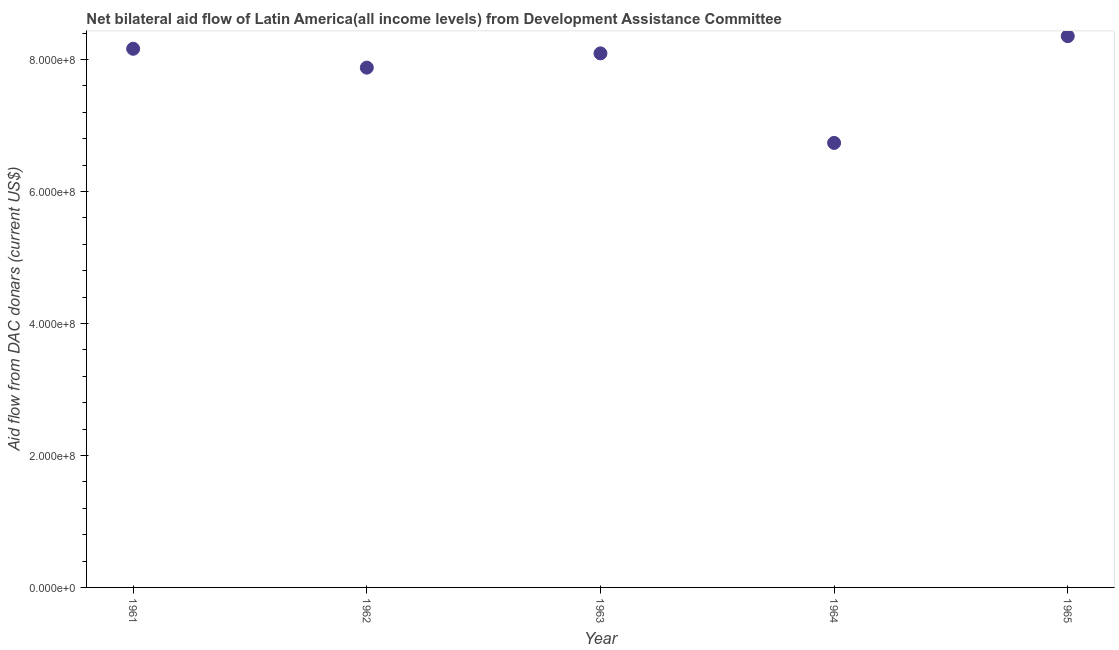What is the net bilateral aid flows from dac donors in 1964?
Provide a succinct answer. 6.74e+08. Across all years, what is the maximum net bilateral aid flows from dac donors?
Offer a terse response. 8.35e+08. Across all years, what is the minimum net bilateral aid flows from dac donors?
Give a very brief answer. 6.74e+08. In which year was the net bilateral aid flows from dac donors maximum?
Provide a short and direct response. 1965. In which year was the net bilateral aid flows from dac donors minimum?
Your response must be concise. 1964. What is the sum of the net bilateral aid flows from dac donors?
Keep it short and to the point. 3.92e+09. What is the difference between the net bilateral aid flows from dac donors in 1962 and 1963?
Your answer should be very brief. -2.16e+07. What is the average net bilateral aid flows from dac donors per year?
Make the answer very short. 7.84e+08. What is the median net bilateral aid flows from dac donors?
Offer a terse response. 8.09e+08. In how many years, is the net bilateral aid flows from dac donors greater than 680000000 US$?
Make the answer very short. 4. Do a majority of the years between 1961 and 1964 (inclusive) have net bilateral aid flows from dac donors greater than 760000000 US$?
Provide a short and direct response. Yes. What is the ratio of the net bilateral aid flows from dac donors in 1961 to that in 1964?
Give a very brief answer. 1.21. Is the difference between the net bilateral aid flows from dac donors in 1962 and 1965 greater than the difference between any two years?
Offer a very short reply. No. What is the difference between the highest and the second highest net bilateral aid flows from dac donors?
Provide a short and direct response. 1.91e+07. Is the sum of the net bilateral aid flows from dac donors in 1961 and 1963 greater than the maximum net bilateral aid flows from dac donors across all years?
Offer a terse response. Yes. What is the difference between the highest and the lowest net bilateral aid flows from dac donors?
Make the answer very short. 1.62e+08. What is the title of the graph?
Ensure brevity in your answer.  Net bilateral aid flow of Latin America(all income levels) from Development Assistance Committee. What is the label or title of the X-axis?
Provide a short and direct response. Year. What is the label or title of the Y-axis?
Your answer should be compact. Aid flow from DAC donars (current US$). What is the Aid flow from DAC donars (current US$) in 1961?
Offer a terse response. 8.16e+08. What is the Aid flow from DAC donars (current US$) in 1962?
Ensure brevity in your answer.  7.88e+08. What is the Aid flow from DAC donars (current US$) in 1963?
Offer a very short reply. 8.09e+08. What is the Aid flow from DAC donars (current US$) in 1964?
Ensure brevity in your answer.  6.74e+08. What is the Aid flow from DAC donars (current US$) in 1965?
Your answer should be compact. 8.35e+08. What is the difference between the Aid flow from DAC donars (current US$) in 1961 and 1962?
Offer a terse response. 2.86e+07. What is the difference between the Aid flow from DAC donars (current US$) in 1961 and 1963?
Make the answer very short. 6.97e+06. What is the difference between the Aid flow from DAC donars (current US$) in 1961 and 1964?
Ensure brevity in your answer.  1.43e+08. What is the difference between the Aid flow from DAC donars (current US$) in 1961 and 1965?
Give a very brief answer. -1.91e+07. What is the difference between the Aid flow from DAC donars (current US$) in 1962 and 1963?
Offer a very short reply. -2.16e+07. What is the difference between the Aid flow from DAC donars (current US$) in 1962 and 1964?
Make the answer very short. 1.14e+08. What is the difference between the Aid flow from DAC donars (current US$) in 1962 and 1965?
Your answer should be very brief. -4.77e+07. What is the difference between the Aid flow from DAC donars (current US$) in 1963 and 1964?
Provide a succinct answer. 1.36e+08. What is the difference between the Aid flow from DAC donars (current US$) in 1963 and 1965?
Make the answer very short. -2.61e+07. What is the difference between the Aid flow from DAC donars (current US$) in 1964 and 1965?
Give a very brief answer. -1.62e+08. What is the ratio of the Aid flow from DAC donars (current US$) in 1961 to that in 1962?
Provide a short and direct response. 1.04. What is the ratio of the Aid flow from DAC donars (current US$) in 1961 to that in 1963?
Offer a terse response. 1.01. What is the ratio of the Aid flow from DAC donars (current US$) in 1961 to that in 1964?
Provide a short and direct response. 1.21. What is the ratio of the Aid flow from DAC donars (current US$) in 1961 to that in 1965?
Your response must be concise. 0.98. What is the ratio of the Aid flow from DAC donars (current US$) in 1962 to that in 1963?
Provide a short and direct response. 0.97. What is the ratio of the Aid flow from DAC donars (current US$) in 1962 to that in 1964?
Provide a succinct answer. 1.17. What is the ratio of the Aid flow from DAC donars (current US$) in 1962 to that in 1965?
Offer a terse response. 0.94. What is the ratio of the Aid flow from DAC donars (current US$) in 1963 to that in 1964?
Offer a very short reply. 1.2. What is the ratio of the Aid flow from DAC donars (current US$) in 1963 to that in 1965?
Offer a terse response. 0.97. What is the ratio of the Aid flow from DAC donars (current US$) in 1964 to that in 1965?
Provide a succinct answer. 0.81. 